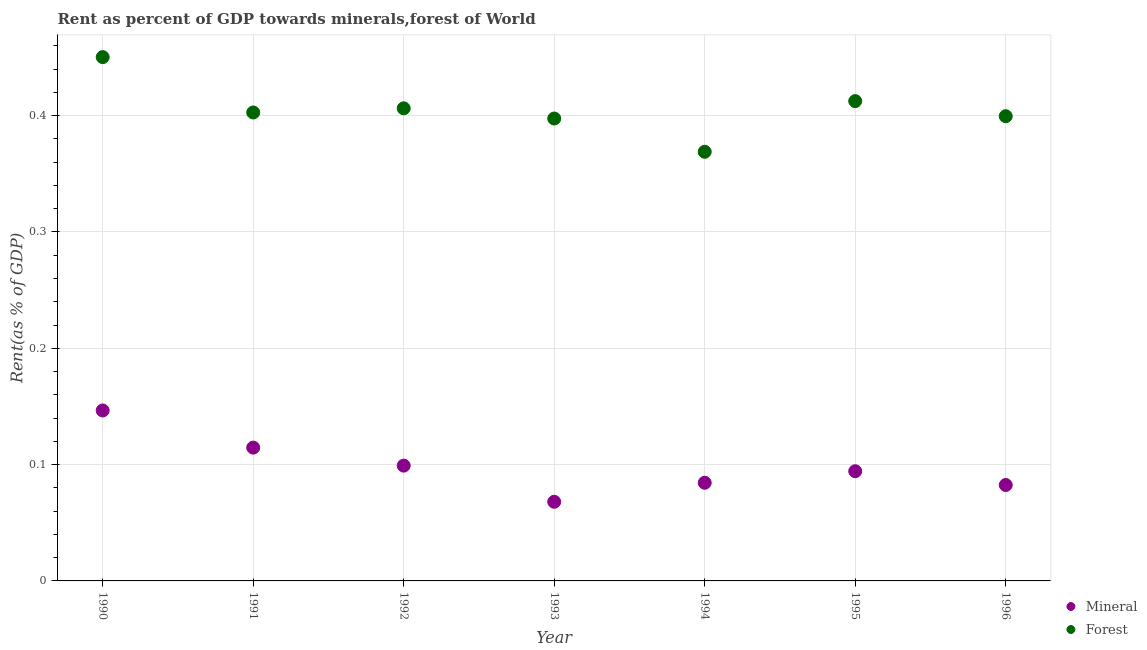How many different coloured dotlines are there?
Offer a terse response. 2. What is the forest rent in 1990?
Make the answer very short. 0.45. Across all years, what is the maximum forest rent?
Provide a succinct answer. 0.45. Across all years, what is the minimum forest rent?
Provide a short and direct response. 0.37. What is the total mineral rent in the graph?
Give a very brief answer. 0.69. What is the difference between the forest rent in 1992 and that in 1996?
Your response must be concise. 0.01. What is the difference between the mineral rent in 1994 and the forest rent in 1996?
Offer a very short reply. -0.32. What is the average forest rent per year?
Your answer should be compact. 0.41. In the year 1994, what is the difference between the mineral rent and forest rent?
Keep it short and to the point. -0.28. What is the ratio of the mineral rent in 1993 to that in 1995?
Provide a short and direct response. 0.72. Is the difference between the forest rent in 1993 and 1994 greater than the difference between the mineral rent in 1993 and 1994?
Provide a succinct answer. Yes. What is the difference between the highest and the second highest forest rent?
Provide a short and direct response. 0.04. What is the difference between the highest and the lowest forest rent?
Provide a short and direct response. 0.08. In how many years, is the forest rent greater than the average forest rent taken over all years?
Provide a short and direct response. 3. Is the sum of the forest rent in 1994 and 1995 greater than the maximum mineral rent across all years?
Provide a short and direct response. Yes. Does the forest rent monotonically increase over the years?
Ensure brevity in your answer.  No. Is the forest rent strictly less than the mineral rent over the years?
Offer a terse response. No. Does the graph contain any zero values?
Give a very brief answer. No. Does the graph contain grids?
Your answer should be very brief. Yes. Where does the legend appear in the graph?
Ensure brevity in your answer.  Bottom right. How many legend labels are there?
Your answer should be very brief. 2. What is the title of the graph?
Offer a terse response. Rent as percent of GDP towards minerals,forest of World. Does "Drinking water services" appear as one of the legend labels in the graph?
Provide a short and direct response. No. What is the label or title of the Y-axis?
Keep it short and to the point. Rent(as % of GDP). What is the Rent(as % of GDP) of Mineral in 1990?
Keep it short and to the point. 0.15. What is the Rent(as % of GDP) of Forest in 1990?
Ensure brevity in your answer.  0.45. What is the Rent(as % of GDP) in Mineral in 1991?
Offer a terse response. 0.11. What is the Rent(as % of GDP) in Forest in 1991?
Your answer should be compact. 0.4. What is the Rent(as % of GDP) of Mineral in 1992?
Keep it short and to the point. 0.1. What is the Rent(as % of GDP) of Forest in 1992?
Offer a terse response. 0.41. What is the Rent(as % of GDP) of Mineral in 1993?
Keep it short and to the point. 0.07. What is the Rent(as % of GDP) in Forest in 1993?
Your answer should be very brief. 0.4. What is the Rent(as % of GDP) in Mineral in 1994?
Your answer should be compact. 0.08. What is the Rent(as % of GDP) in Forest in 1994?
Your answer should be compact. 0.37. What is the Rent(as % of GDP) of Mineral in 1995?
Keep it short and to the point. 0.09. What is the Rent(as % of GDP) of Forest in 1995?
Your answer should be very brief. 0.41. What is the Rent(as % of GDP) in Mineral in 1996?
Offer a very short reply. 0.08. What is the Rent(as % of GDP) of Forest in 1996?
Provide a succinct answer. 0.4. Across all years, what is the maximum Rent(as % of GDP) of Mineral?
Ensure brevity in your answer.  0.15. Across all years, what is the maximum Rent(as % of GDP) of Forest?
Your response must be concise. 0.45. Across all years, what is the minimum Rent(as % of GDP) of Mineral?
Provide a succinct answer. 0.07. Across all years, what is the minimum Rent(as % of GDP) in Forest?
Provide a short and direct response. 0.37. What is the total Rent(as % of GDP) in Mineral in the graph?
Provide a succinct answer. 0.69. What is the total Rent(as % of GDP) in Forest in the graph?
Make the answer very short. 2.84. What is the difference between the Rent(as % of GDP) in Mineral in 1990 and that in 1991?
Give a very brief answer. 0.03. What is the difference between the Rent(as % of GDP) in Forest in 1990 and that in 1991?
Give a very brief answer. 0.05. What is the difference between the Rent(as % of GDP) of Mineral in 1990 and that in 1992?
Your answer should be compact. 0.05. What is the difference between the Rent(as % of GDP) in Forest in 1990 and that in 1992?
Your answer should be compact. 0.04. What is the difference between the Rent(as % of GDP) in Mineral in 1990 and that in 1993?
Provide a succinct answer. 0.08. What is the difference between the Rent(as % of GDP) in Forest in 1990 and that in 1993?
Offer a terse response. 0.05. What is the difference between the Rent(as % of GDP) in Mineral in 1990 and that in 1994?
Provide a short and direct response. 0.06. What is the difference between the Rent(as % of GDP) in Forest in 1990 and that in 1994?
Ensure brevity in your answer.  0.08. What is the difference between the Rent(as % of GDP) of Mineral in 1990 and that in 1995?
Offer a terse response. 0.05. What is the difference between the Rent(as % of GDP) of Forest in 1990 and that in 1995?
Offer a terse response. 0.04. What is the difference between the Rent(as % of GDP) in Mineral in 1990 and that in 1996?
Your answer should be compact. 0.06. What is the difference between the Rent(as % of GDP) of Forest in 1990 and that in 1996?
Offer a very short reply. 0.05. What is the difference between the Rent(as % of GDP) in Mineral in 1991 and that in 1992?
Ensure brevity in your answer.  0.02. What is the difference between the Rent(as % of GDP) in Forest in 1991 and that in 1992?
Keep it short and to the point. -0. What is the difference between the Rent(as % of GDP) of Mineral in 1991 and that in 1993?
Offer a very short reply. 0.05. What is the difference between the Rent(as % of GDP) of Forest in 1991 and that in 1993?
Your response must be concise. 0.01. What is the difference between the Rent(as % of GDP) of Mineral in 1991 and that in 1994?
Ensure brevity in your answer.  0.03. What is the difference between the Rent(as % of GDP) of Forest in 1991 and that in 1994?
Provide a short and direct response. 0.03. What is the difference between the Rent(as % of GDP) of Mineral in 1991 and that in 1995?
Make the answer very short. 0.02. What is the difference between the Rent(as % of GDP) in Forest in 1991 and that in 1995?
Provide a succinct answer. -0.01. What is the difference between the Rent(as % of GDP) of Mineral in 1991 and that in 1996?
Make the answer very short. 0.03. What is the difference between the Rent(as % of GDP) in Forest in 1991 and that in 1996?
Your response must be concise. 0. What is the difference between the Rent(as % of GDP) of Mineral in 1992 and that in 1993?
Offer a terse response. 0.03. What is the difference between the Rent(as % of GDP) in Forest in 1992 and that in 1993?
Your answer should be very brief. 0.01. What is the difference between the Rent(as % of GDP) of Mineral in 1992 and that in 1994?
Your response must be concise. 0.01. What is the difference between the Rent(as % of GDP) in Forest in 1992 and that in 1994?
Your answer should be compact. 0.04. What is the difference between the Rent(as % of GDP) in Mineral in 1992 and that in 1995?
Give a very brief answer. 0. What is the difference between the Rent(as % of GDP) in Forest in 1992 and that in 1995?
Your answer should be very brief. -0.01. What is the difference between the Rent(as % of GDP) in Mineral in 1992 and that in 1996?
Ensure brevity in your answer.  0.02. What is the difference between the Rent(as % of GDP) in Forest in 1992 and that in 1996?
Provide a short and direct response. 0.01. What is the difference between the Rent(as % of GDP) of Mineral in 1993 and that in 1994?
Provide a short and direct response. -0.02. What is the difference between the Rent(as % of GDP) in Forest in 1993 and that in 1994?
Offer a terse response. 0.03. What is the difference between the Rent(as % of GDP) in Mineral in 1993 and that in 1995?
Keep it short and to the point. -0.03. What is the difference between the Rent(as % of GDP) in Forest in 1993 and that in 1995?
Provide a succinct answer. -0.01. What is the difference between the Rent(as % of GDP) in Mineral in 1993 and that in 1996?
Ensure brevity in your answer.  -0.01. What is the difference between the Rent(as % of GDP) in Forest in 1993 and that in 1996?
Give a very brief answer. -0. What is the difference between the Rent(as % of GDP) in Mineral in 1994 and that in 1995?
Make the answer very short. -0.01. What is the difference between the Rent(as % of GDP) of Forest in 1994 and that in 1995?
Your answer should be very brief. -0.04. What is the difference between the Rent(as % of GDP) in Mineral in 1994 and that in 1996?
Your response must be concise. 0. What is the difference between the Rent(as % of GDP) of Forest in 1994 and that in 1996?
Your response must be concise. -0.03. What is the difference between the Rent(as % of GDP) of Mineral in 1995 and that in 1996?
Offer a very short reply. 0.01. What is the difference between the Rent(as % of GDP) of Forest in 1995 and that in 1996?
Provide a short and direct response. 0.01. What is the difference between the Rent(as % of GDP) of Mineral in 1990 and the Rent(as % of GDP) of Forest in 1991?
Your answer should be very brief. -0.26. What is the difference between the Rent(as % of GDP) of Mineral in 1990 and the Rent(as % of GDP) of Forest in 1992?
Offer a terse response. -0.26. What is the difference between the Rent(as % of GDP) of Mineral in 1990 and the Rent(as % of GDP) of Forest in 1993?
Give a very brief answer. -0.25. What is the difference between the Rent(as % of GDP) of Mineral in 1990 and the Rent(as % of GDP) of Forest in 1994?
Your answer should be compact. -0.22. What is the difference between the Rent(as % of GDP) of Mineral in 1990 and the Rent(as % of GDP) of Forest in 1995?
Ensure brevity in your answer.  -0.27. What is the difference between the Rent(as % of GDP) of Mineral in 1990 and the Rent(as % of GDP) of Forest in 1996?
Provide a short and direct response. -0.25. What is the difference between the Rent(as % of GDP) in Mineral in 1991 and the Rent(as % of GDP) in Forest in 1992?
Keep it short and to the point. -0.29. What is the difference between the Rent(as % of GDP) of Mineral in 1991 and the Rent(as % of GDP) of Forest in 1993?
Give a very brief answer. -0.28. What is the difference between the Rent(as % of GDP) in Mineral in 1991 and the Rent(as % of GDP) in Forest in 1994?
Offer a very short reply. -0.25. What is the difference between the Rent(as % of GDP) in Mineral in 1991 and the Rent(as % of GDP) in Forest in 1995?
Your answer should be very brief. -0.3. What is the difference between the Rent(as % of GDP) of Mineral in 1991 and the Rent(as % of GDP) of Forest in 1996?
Offer a terse response. -0.28. What is the difference between the Rent(as % of GDP) of Mineral in 1992 and the Rent(as % of GDP) of Forest in 1993?
Your answer should be very brief. -0.3. What is the difference between the Rent(as % of GDP) of Mineral in 1992 and the Rent(as % of GDP) of Forest in 1994?
Give a very brief answer. -0.27. What is the difference between the Rent(as % of GDP) in Mineral in 1992 and the Rent(as % of GDP) in Forest in 1995?
Provide a succinct answer. -0.31. What is the difference between the Rent(as % of GDP) of Mineral in 1992 and the Rent(as % of GDP) of Forest in 1996?
Offer a terse response. -0.3. What is the difference between the Rent(as % of GDP) of Mineral in 1993 and the Rent(as % of GDP) of Forest in 1994?
Offer a terse response. -0.3. What is the difference between the Rent(as % of GDP) in Mineral in 1993 and the Rent(as % of GDP) in Forest in 1995?
Provide a succinct answer. -0.34. What is the difference between the Rent(as % of GDP) of Mineral in 1993 and the Rent(as % of GDP) of Forest in 1996?
Offer a terse response. -0.33. What is the difference between the Rent(as % of GDP) in Mineral in 1994 and the Rent(as % of GDP) in Forest in 1995?
Your answer should be very brief. -0.33. What is the difference between the Rent(as % of GDP) in Mineral in 1994 and the Rent(as % of GDP) in Forest in 1996?
Ensure brevity in your answer.  -0.32. What is the difference between the Rent(as % of GDP) in Mineral in 1995 and the Rent(as % of GDP) in Forest in 1996?
Offer a very short reply. -0.31. What is the average Rent(as % of GDP) in Mineral per year?
Offer a very short reply. 0.1. What is the average Rent(as % of GDP) of Forest per year?
Your response must be concise. 0.41. In the year 1990, what is the difference between the Rent(as % of GDP) in Mineral and Rent(as % of GDP) in Forest?
Keep it short and to the point. -0.3. In the year 1991, what is the difference between the Rent(as % of GDP) in Mineral and Rent(as % of GDP) in Forest?
Your response must be concise. -0.29. In the year 1992, what is the difference between the Rent(as % of GDP) in Mineral and Rent(as % of GDP) in Forest?
Provide a short and direct response. -0.31. In the year 1993, what is the difference between the Rent(as % of GDP) in Mineral and Rent(as % of GDP) in Forest?
Offer a terse response. -0.33. In the year 1994, what is the difference between the Rent(as % of GDP) of Mineral and Rent(as % of GDP) of Forest?
Give a very brief answer. -0.28. In the year 1995, what is the difference between the Rent(as % of GDP) of Mineral and Rent(as % of GDP) of Forest?
Provide a succinct answer. -0.32. In the year 1996, what is the difference between the Rent(as % of GDP) of Mineral and Rent(as % of GDP) of Forest?
Your response must be concise. -0.32. What is the ratio of the Rent(as % of GDP) in Mineral in 1990 to that in 1991?
Your response must be concise. 1.28. What is the ratio of the Rent(as % of GDP) of Forest in 1990 to that in 1991?
Give a very brief answer. 1.12. What is the ratio of the Rent(as % of GDP) in Mineral in 1990 to that in 1992?
Ensure brevity in your answer.  1.48. What is the ratio of the Rent(as % of GDP) of Forest in 1990 to that in 1992?
Offer a very short reply. 1.11. What is the ratio of the Rent(as % of GDP) in Mineral in 1990 to that in 1993?
Offer a very short reply. 2.15. What is the ratio of the Rent(as % of GDP) of Forest in 1990 to that in 1993?
Provide a short and direct response. 1.13. What is the ratio of the Rent(as % of GDP) in Mineral in 1990 to that in 1994?
Provide a short and direct response. 1.74. What is the ratio of the Rent(as % of GDP) in Forest in 1990 to that in 1994?
Provide a succinct answer. 1.22. What is the ratio of the Rent(as % of GDP) of Mineral in 1990 to that in 1995?
Your answer should be compact. 1.55. What is the ratio of the Rent(as % of GDP) of Forest in 1990 to that in 1995?
Offer a terse response. 1.09. What is the ratio of the Rent(as % of GDP) of Mineral in 1990 to that in 1996?
Your response must be concise. 1.78. What is the ratio of the Rent(as % of GDP) in Forest in 1990 to that in 1996?
Make the answer very short. 1.13. What is the ratio of the Rent(as % of GDP) of Mineral in 1991 to that in 1992?
Keep it short and to the point. 1.16. What is the ratio of the Rent(as % of GDP) of Mineral in 1991 to that in 1993?
Keep it short and to the point. 1.68. What is the ratio of the Rent(as % of GDP) of Forest in 1991 to that in 1993?
Provide a short and direct response. 1.01. What is the ratio of the Rent(as % of GDP) of Mineral in 1991 to that in 1994?
Your response must be concise. 1.36. What is the ratio of the Rent(as % of GDP) of Forest in 1991 to that in 1994?
Offer a terse response. 1.09. What is the ratio of the Rent(as % of GDP) of Mineral in 1991 to that in 1995?
Give a very brief answer. 1.22. What is the ratio of the Rent(as % of GDP) of Forest in 1991 to that in 1995?
Keep it short and to the point. 0.98. What is the ratio of the Rent(as % of GDP) of Mineral in 1991 to that in 1996?
Provide a short and direct response. 1.39. What is the ratio of the Rent(as % of GDP) in Forest in 1991 to that in 1996?
Give a very brief answer. 1.01. What is the ratio of the Rent(as % of GDP) of Mineral in 1992 to that in 1993?
Your answer should be very brief. 1.46. What is the ratio of the Rent(as % of GDP) in Forest in 1992 to that in 1993?
Your answer should be very brief. 1.02. What is the ratio of the Rent(as % of GDP) in Mineral in 1992 to that in 1994?
Provide a short and direct response. 1.17. What is the ratio of the Rent(as % of GDP) in Forest in 1992 to that in 1994?
Ensure brevity in your answer.  1.1. What is the ratio of the Rent(as % of GDP) of Mineral in 1992 to that in 1995?
Provide a succinct answer. 1.05. What is the ratio of the Rent(as % of GDP) of Forest in 1992 to that in 1995?
Ensure brevity in your answer.  0.98. What is the ratio of the Rent(as % of GDP) of Mineral in 1992 to that in 1996?
Your response must be concise. 1.2. What is the ratio of the Rent(as % of GDP) of Mineral in 1993 to that in 1994?
Keep it short and to the point. 0.81. What is the ratio of the Rent(as % of GDP) in Forest in 1993 to that in 1994?
Give a very brief answer. 1.08. What is the ratio of the Rent(as % of GDP) in Mineral in 1993 to that in 1995?
Ensure brevity in your answer.  0.72. What is the ratio of the Rent(as % of GDP) of Forest in 1993 to that in 1995?
Ensure brevity in your answer.  0.96. What is the ratio of the Rent(as % of GDP) of Mineral in 1993 to that in 1996?
Your answer should be compact. 0.83. What is the ratio of the Rent(as % of GDP) in Forest in 1993 to that in 1996?
Ensure brevity in your answer.  0.99. What is the ratio of the Rent(as % of GDP) in Mineral in 1994 to that in 1995?
Provide a succinct answer. 0.89. What is the ratio of the Rent(as % of GDP) of Forest in 1994 to that in 1995?
Provide a succinct answer. 0.89. What is the ratio of the Rent(as % of GDP) in Mineral in 1994 to that in 1996?
Make the answer very short. 1.02. What is the ratio of the Rent(as % of GDP) of Forest in 1994 to that in 1996?
Make the answer very short. 0.92. What is the ratio of the Rent(as % of GDP) in Mineral in 1995 to that in 1996?
Your response must be concise. 1.14. What is the ratio of the Rent(as % of GDP) in Forest in 1995 to that in 1996?
Provide a short and direct response. 1.03. What is the difference between the highest and the second highest Rent(as % of GDP) in Mineral?
Your answer should be compact. 0.03. What is the difference between the highest and the second highest Rent(as % of GDP) of Forest?
Your response must be concise. 0.04. What is the difference between the highest and the lowest Rent(as % of GDP) of Mineral?
Provide a short and direct response. 0.08. What is the difference between the highest and the lowest Rent(as % of GDP) in Forest?
Offer a terse response. 0.08. 